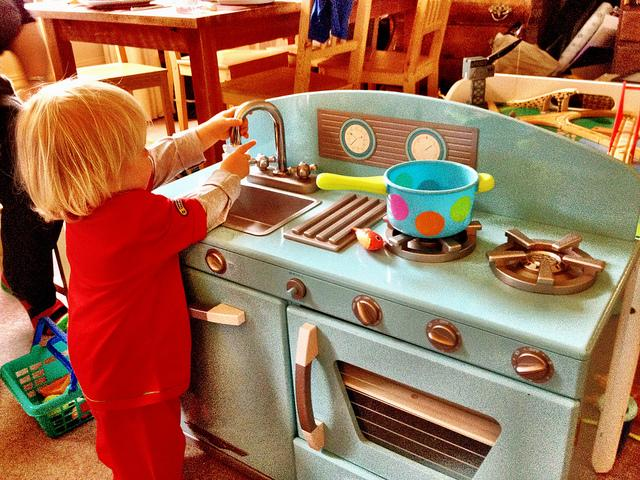What will come out of the sink?

Choices:
A) water
B) nothing
C) gasoline
D) soda nothing 